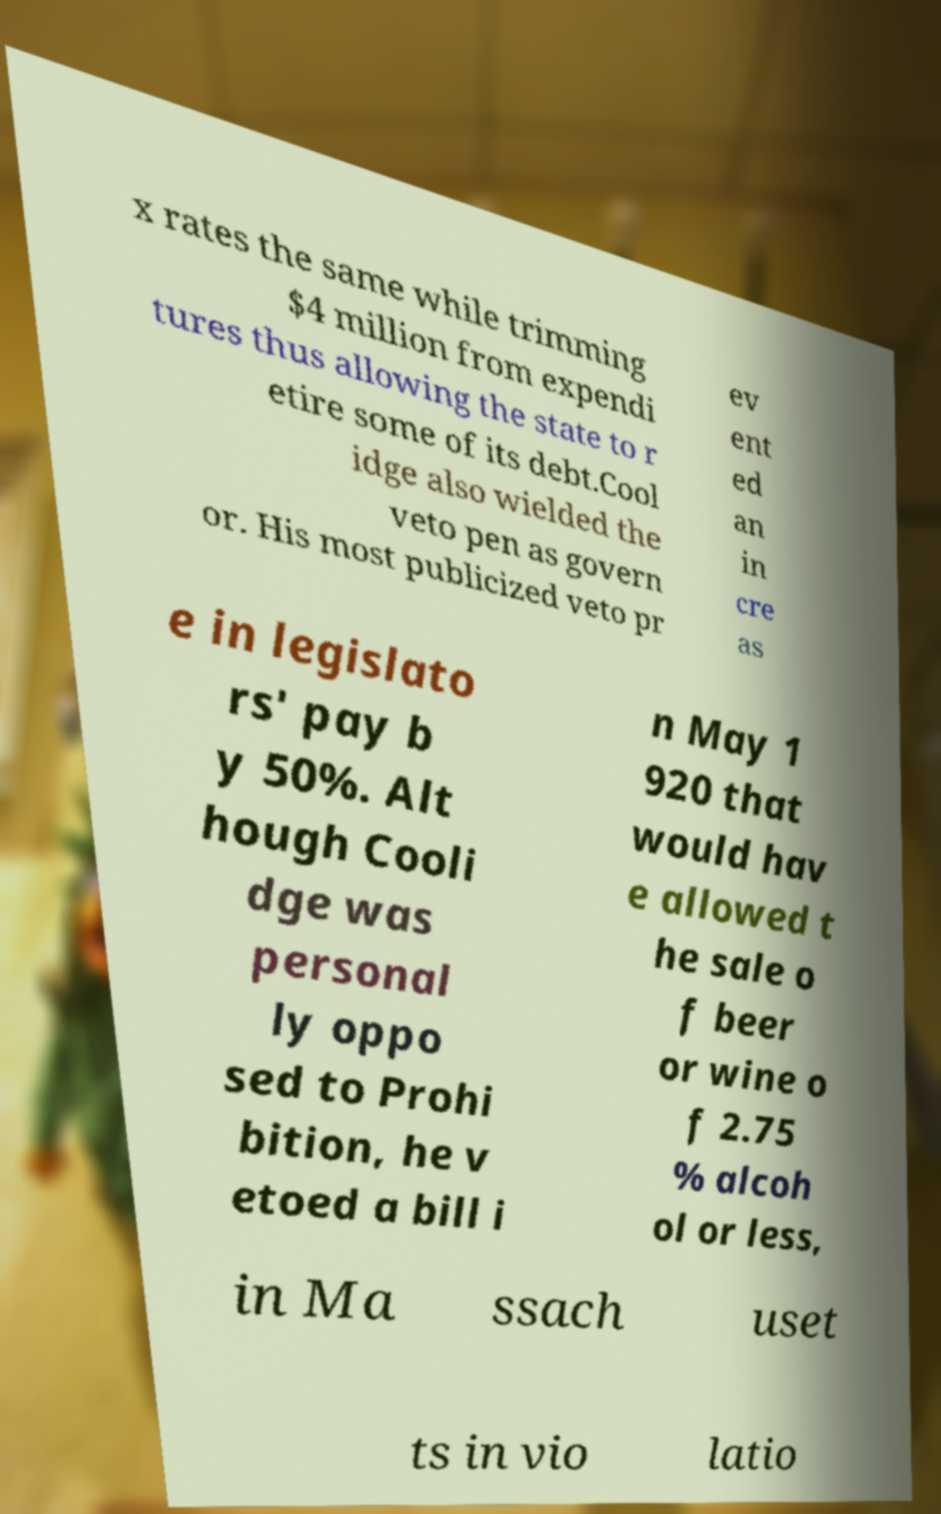I need the written content from this picture converted into text. Can you do that? x rates the same while trimming $4 million from expendi tures thus allowing the state to r etire some of its debt.Cool idge also wielded the veto pen as govern or. His most publicized veto pr ev ent ed an in cre as e in legislato rs' pay b y 50%. Alt hough Cooli dge was personal ly oppo sed to Prohi bition, he v etoed a bill i n May 1 920 that would hav e allowed t he sale o f beer or wine o f 2.75 % alcoh ol or less, in Ma ssach uset ts in vio latio 